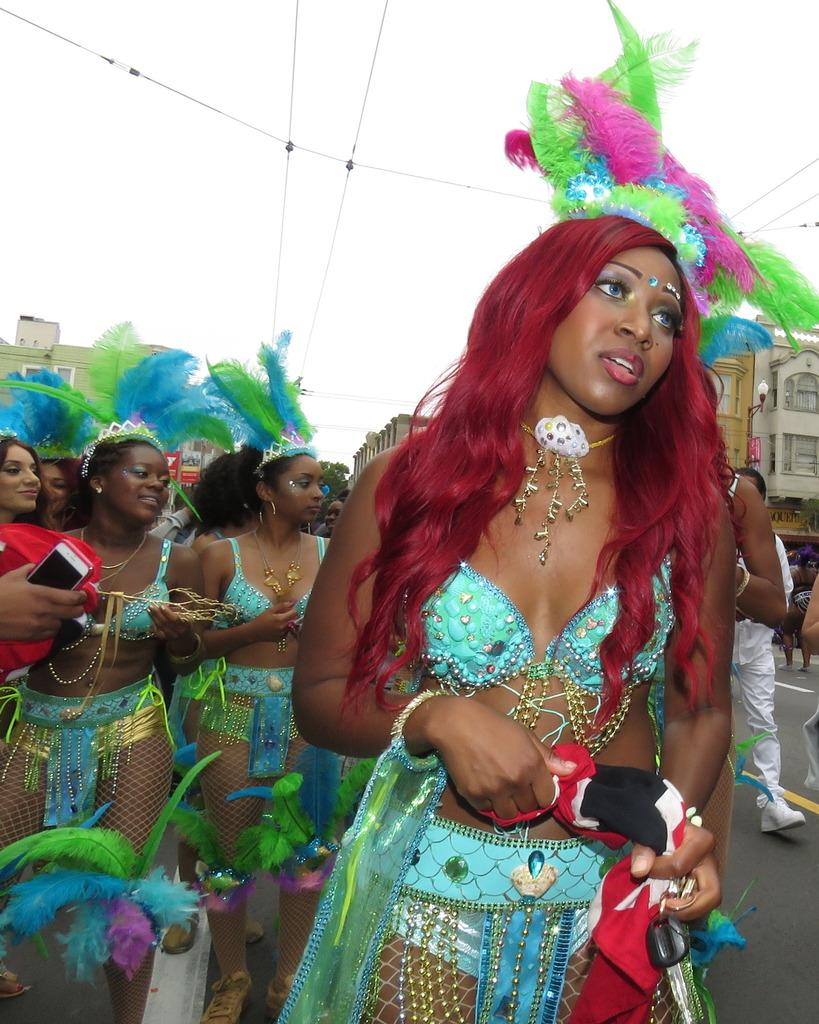Who is present in the image? There are women and a man in the image. Can you describe the man's position in the image? The man is on the right side of the image. What can be seen in the background of the image? There are two buildings in the background of the image. What is visible at the top of the image? The sky is visible at the top of the image. What type of army is depicted in the image? There is no army present in the image; it features women and a man in a setting with buildings and sky. 